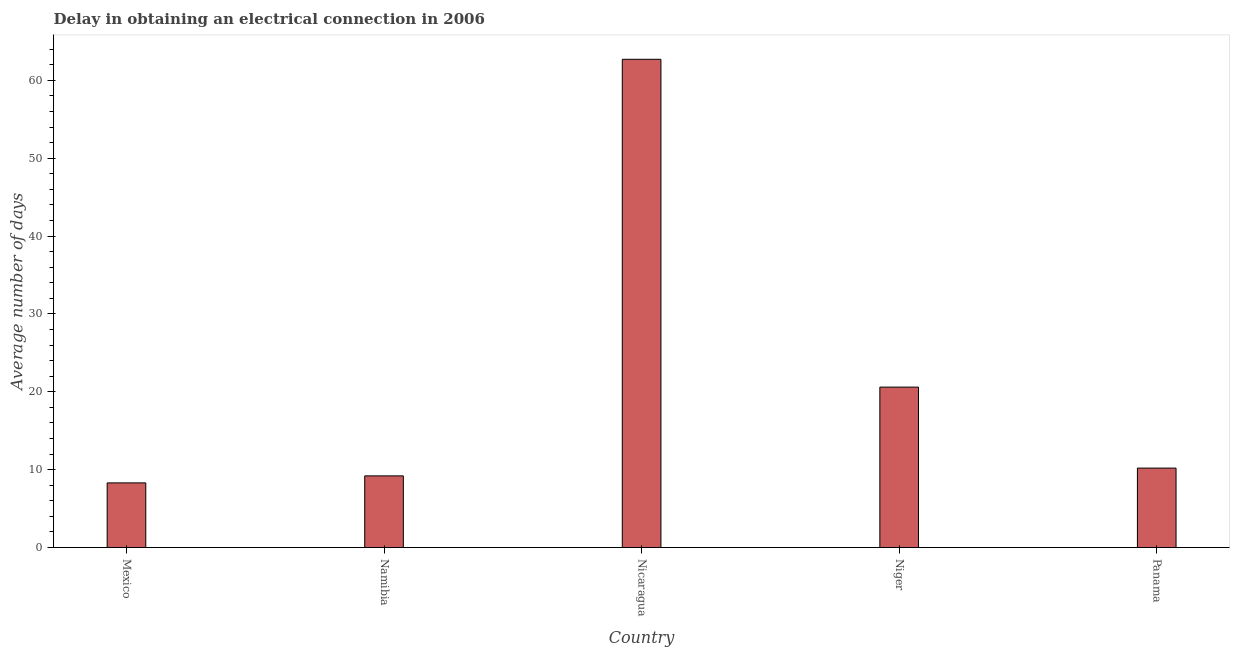Does the graph contain any zero values?
Your answer should be very brief. No. Does the graph contain grids?
Provide a short and direct response. No. What is the title of the graph?
Offer a very short reply. Delay in obtaining an electrical connection in 2006. What is the label or title of the X-axis?
Ensure brevity in your answer.  Country. What is the label or title of the Y-axis?
Your answer should be compact. Average number of days. What is the dalay in electrical connection in Nicaragua?
Ensure brevity in your answer.  62.7. Across all countries, what is the maximum dalay in electrical connection?
Your answer should be very brief. 62.7. In which country was the dalay in electrical connection maximum?
Keep it short and to the point. Nicaragua. What is the sum of the dalay in electrical connection?
Provide a short and direct response. 111. What is the difference between the dalay in electrical connection in Namibia and Nicaragua?
Provide a succinct answer. -53.5. What is the average dalay in electrical connection per country?
Offer a very short reply. 22.2. What is the ratio of the dalay in electrical connection in Niger to that in Panama?
Provide a succinct answer. 2.02. What is the difference between the highest and the second highest dalay in electrical connection?
Offer a terse response. 42.1. What is the difference between the highest and the lowest dalay in electrical connection?
Keep it short and to the point. 54.4. In how many countries, is the dalay in electrical connection greater than the average dalay in electrical connection taken over all countries?
Your answer should be compact. 1. How many bars are there?
Offer a terse response. 5. Are all the bars in the graph horizontal?
Make the answer very short. No. Are the values on the major ticks of Y-axis written in scientific E-notation?
Provide a short and direct response. No. What is the Average number of days of Mexico?
Your answer should be compact. 8.3. What is the Average number of days in Namibia?
Provide a short and direct response. 9.2. What is the Average number of days of Nicaragua?
Your answer should be very brief. 62.7. What is the Average number of days of Niger?
Make the answer very short. 20.6. What is the difference between the Average number of days in Mexico and Nicaragua?
Make the answer very short. -54.4. What is the difference between the Average number of days in Namibia and Nicaragua?
Your answer should be compact. -53.5. What is the difference between the Average number of days in Namibia and Niger?
Provide a succinct answer. -11.4. What is the difference between the Average number of days in Namibia and Panama?
Give a very brief answer. -1. What is the difference between the Average number of days in Nicaragua and Niger?
Offer a terse response. 42.1. What is the difference between the Average number of days in Nicaragua and Panama?
Make the answer very short. 52.5. What is the ratio of the Average number of days in Mexico to that in Namibia?
Ensure brevity in your answer.  0.9. What is the ratio of the Average number of days in Mexico to that in Nicaragua?
Offer a terse response. 0.13. What is the ratio of the Average number of days in Mexico to that in Niger?
Provide a succinct answer. 0.4. What is the ratio of the Average number of days in Mexico to that in Panama?
Your answer should be compact. 0.81. What is the ratio of the Average number of days in Namibia to that in Nicaragua?
Give a very brief answer. 0.15. What is the ratio of the Average number of days in Namibia to that in Niger?
Your answer should be compact. 0.45. What is the ratio of the Average number of days in Namibia to that in Panama?
Ensure brevity in your answer.  0.9. What is the ratio of the Average number of days in Nicaragua to that in Niger?
Your answer should be compact. 3.04. What is the ratio of the Average number of days in Nicaragua to that in Panama?
Ensure brevity in your answer.  6.15. What is the ratio of the Average number of days in Niger to that in Panama?
Make the answer very short. 2.02. 